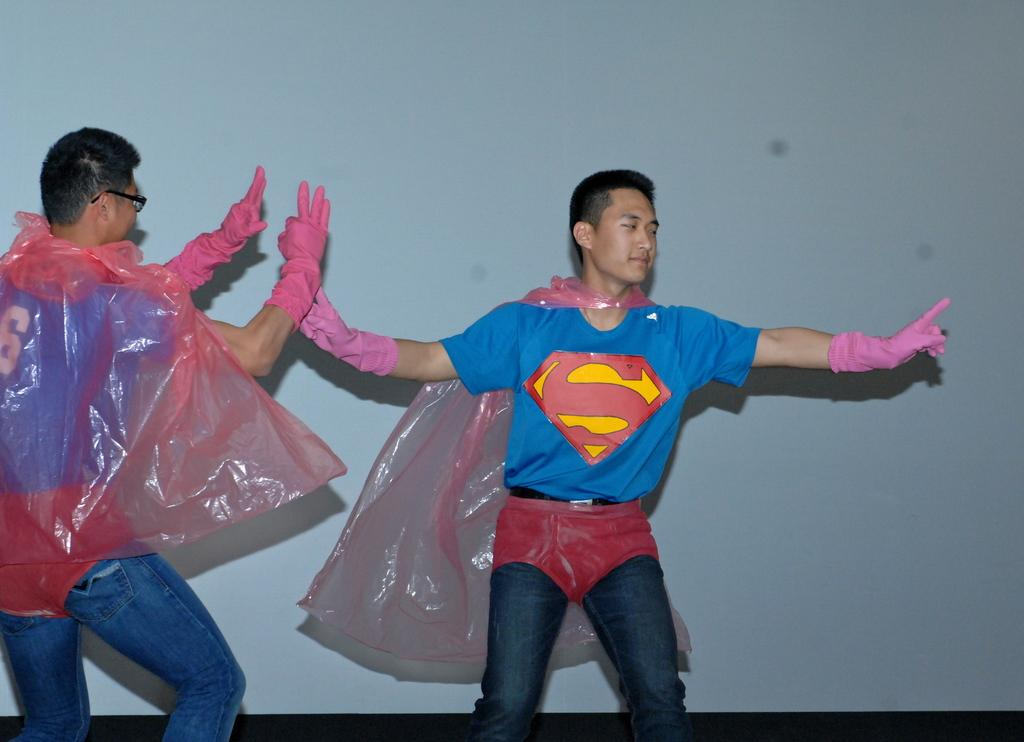How many people are in the image? There are two men in the image. What are the men wearing on their hands? The men are wearing gloves. What activity are the men engaged in? The men are dancing. What can be seen in the background of the image? There is a wall in the background of the image. What type of chess piece is the man holding in the image? There is no chess piece present in the image; the men are wearing gloves and dancing. How does the man's expression show disgust in the image? The men's expressions are not described in the image, and there is no indication of disgust. 